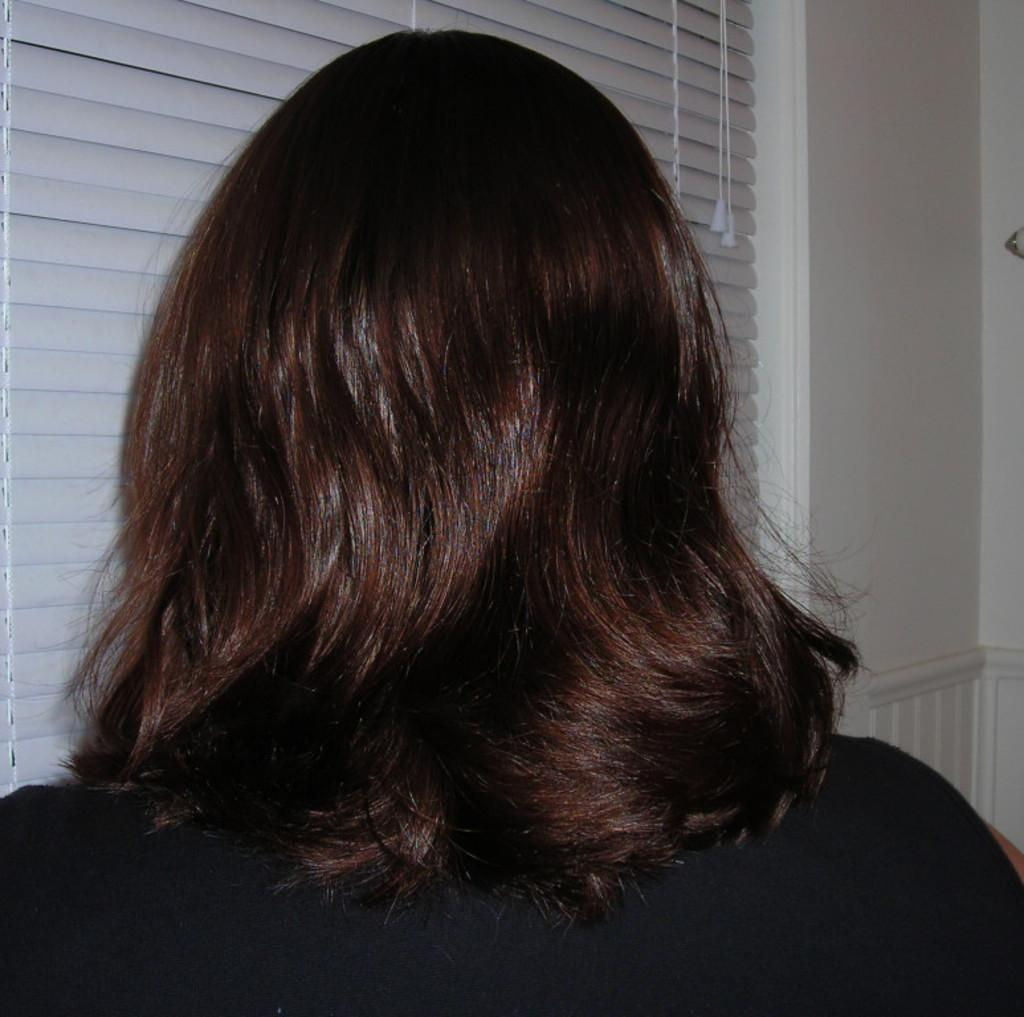Who is present in the image? There is a lady in the image. What can be seen in the background of the image? There is a wall in the background of the image. Is there any opening in the wall visible in the image? Yes, there is a window in the image. What is the rate of the leaf falling in the image? There is no leaf present in the image, so it is not possible to determine the rate of a leaf falling. 